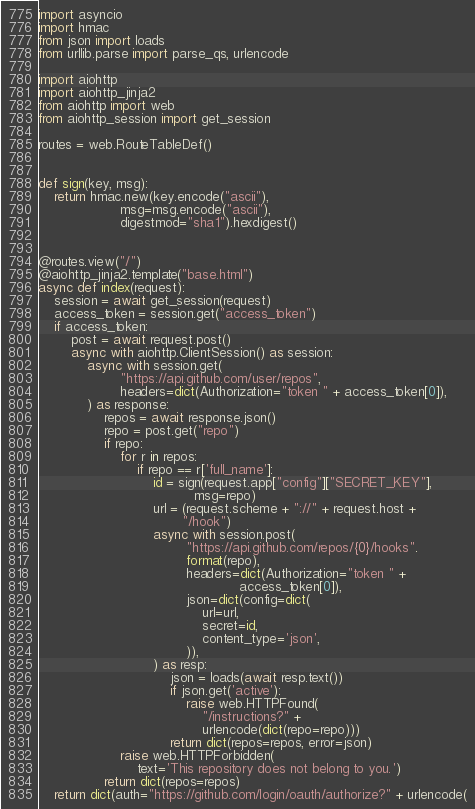<code> <loc_0><loc_0><loc_500><loc_500><_Python_>import asyncio
import hmac
from json import loads
from urllib.parse import parse_qs, urlencode

import aiohttp
import aiohttp_jinja2
from aiohttp import web
from aiohttp_session import get_session

routes = web.RouteTableDef()


def sign(key, msg):
    return hmac.new(key.encode("ascii"),
                    msg=msg.encode("ascii"),
                    digestmod="sha1").hexdigest()


@routes.view("/")
@aiohttp_jinja2.template("base.html")
async def index(request):
    session = await get_session(request)
    access_token = session.get("access_token")
    if access_token:
        post = await request.post()
        async with aiohttp.ClientSession() as session:
            async with session.get(
                    "https://api.github.com/user/repos",
                    headers=dict(Authorization="token " + access_token[0]),
            ) as response:
                repos = await response.json()
                repo = post.get("repo")
                if repo:
                    for r in repos:
                        if repo == r['full_name']:
                            id = sign(request.app["config"]["SECRET_KEY"],
                                      msg=repo)
                            url = (request.scheme + "://" + request.host +
                                   "/hook")
                            async with session.post(
                                    "https://api.github.com/repos/{0}/hooks".
                                    format(repo),
                                    headers=dict(Authorization="token " +
                                                 access_token[0]),
                                    json=dict(config=dict(
                                        url=url,
                                        secret=id,
                                        content_type='json',
                                    )),
                            ) as resp:
                                json = loads(await resp.text())
                                if json.get('active'):
                                    raise web.HTTPFound(
                                        "/instructions?" +
                                        urlencode(dict(repo=repo)))
                                return dict(repos=repos, error=json)
                    raise web.HTTPForbidden(
                        text='This repository does not belong to you.')
                return dict(repos=repos)
    return dict(auth="https://github.com/login/oauth/authorize?" + urlencode(</code> 